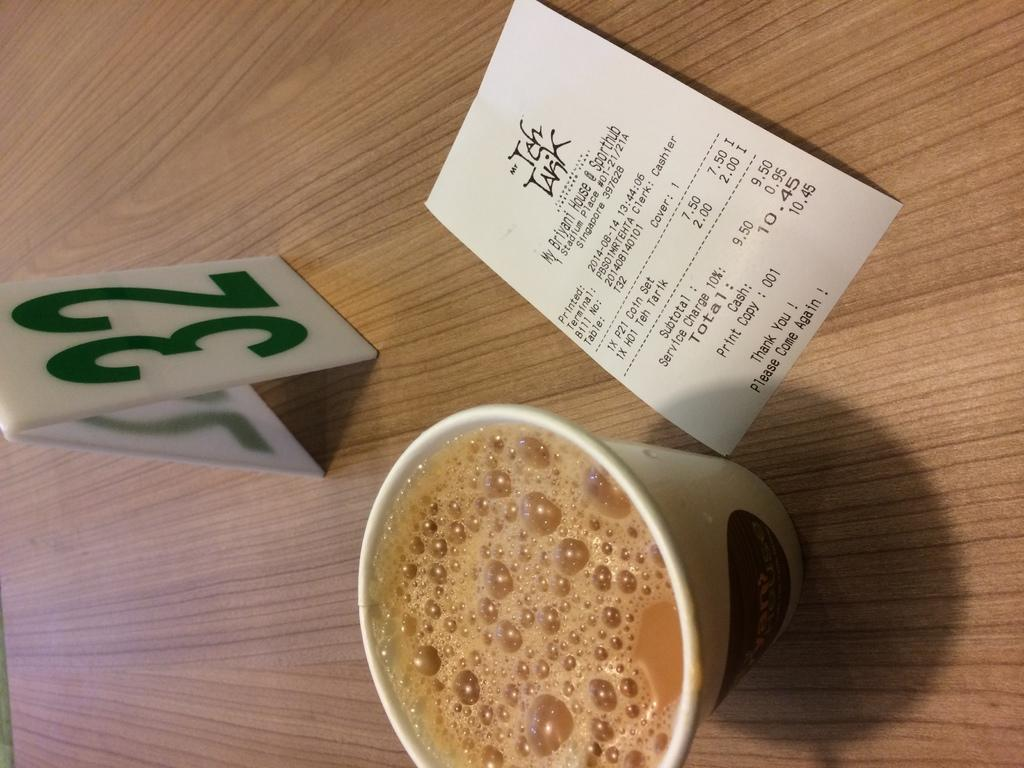What piece of furniture is present in the image? There is a table in the image. What is in the glass on the table? There is tea in the glass on the table. What type of document is visible in the image? There is a bill in the image. What is the purpose of the number board on the table? The number board on the table is likely used for keeping track of numbers or orders. What type of music is the band playing in the image? There is no band present in the image, so it is not possible to determine what type of music they might be playing. 